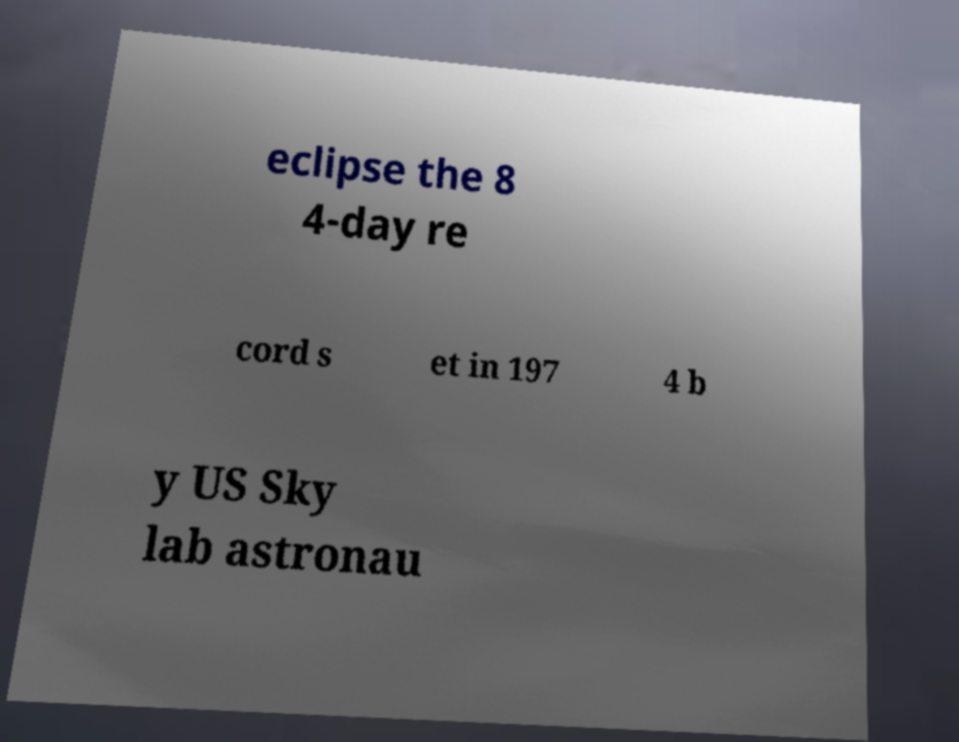Please identify and transcribe the text found in this image. eclipse the 8 4-day re cord s et in 197 4 b y US Sky lab astronau 